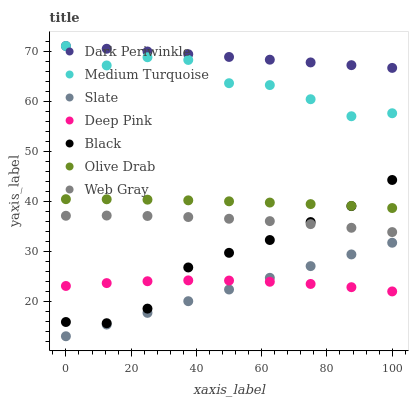Does Slate have the minimum area under the curve?
Answer yes or no. Yes. Does Dark Periwinkle have the maximum area under the curve?
Answer yes or no. Yes. Does Web Gray have the minimum area under the curve?
Answer yes or no. No. Does Web Gray have the maximum area under the curve?
Answer yes or no. No. Is Slate the smoothest?
Answer yes or no. Yes. Is Medium Turquoise the roughest?
Answer yes or no. Yes. Is Web Gray the smoothest?
Answer yes or no. No. Is Web Gray the roughest?
Answer yes or no. No. Does Slate have the lowest value?
Answer yes or no. Yes. Does Web Gray have the lowest value?
Answer yes or no. No. Does Dark Periwinkle have the highest value?
Answer yes or no. Yes. Does Slate have the highest value?
Answer yes or no. No. Is Slate less than Web Gray?
Answer yes or no. Yes. Is Medium Turquoise greater than Olive Drab?
Answer yes or no. Yes. Does Dark Periwinkle intersect Medium Turquoise?
Answer yes or no. Yes. Is Dark Periwinkle less than Medium Turquoise?
Answer yes or no. No. Is Dark Periwinkle greater than Medium Turquoise?
Answer yes or no. No. Does Slate intersect Web Gray?
Answer yes or no. No. 